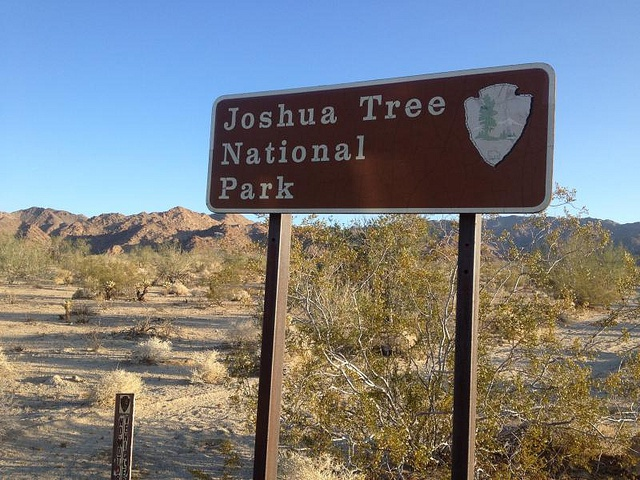Describe the objects in this image and their specific colors. I can see various objects in this image with different colors. 